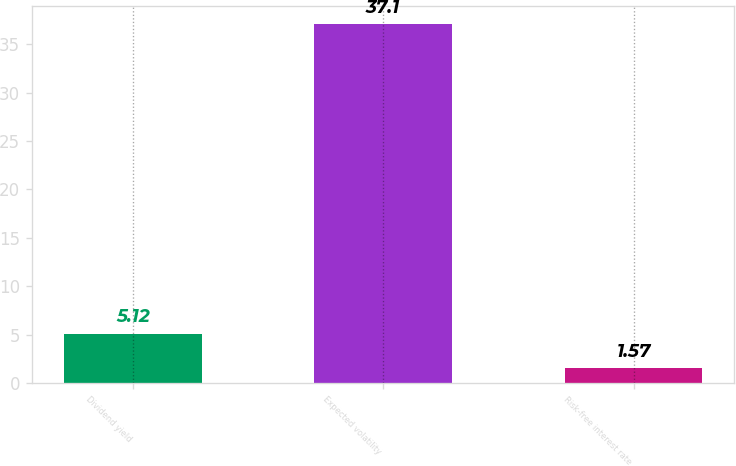<chart> <loc_0><loc_0><loc_500><loc_500><bar_chart><fcel>Dividend yield<fcel>Expected volatility<fcel>Risk-free interest rate<nl><fcel>5.12<fcel>37.1<fcel>1.57<nl></chart> 